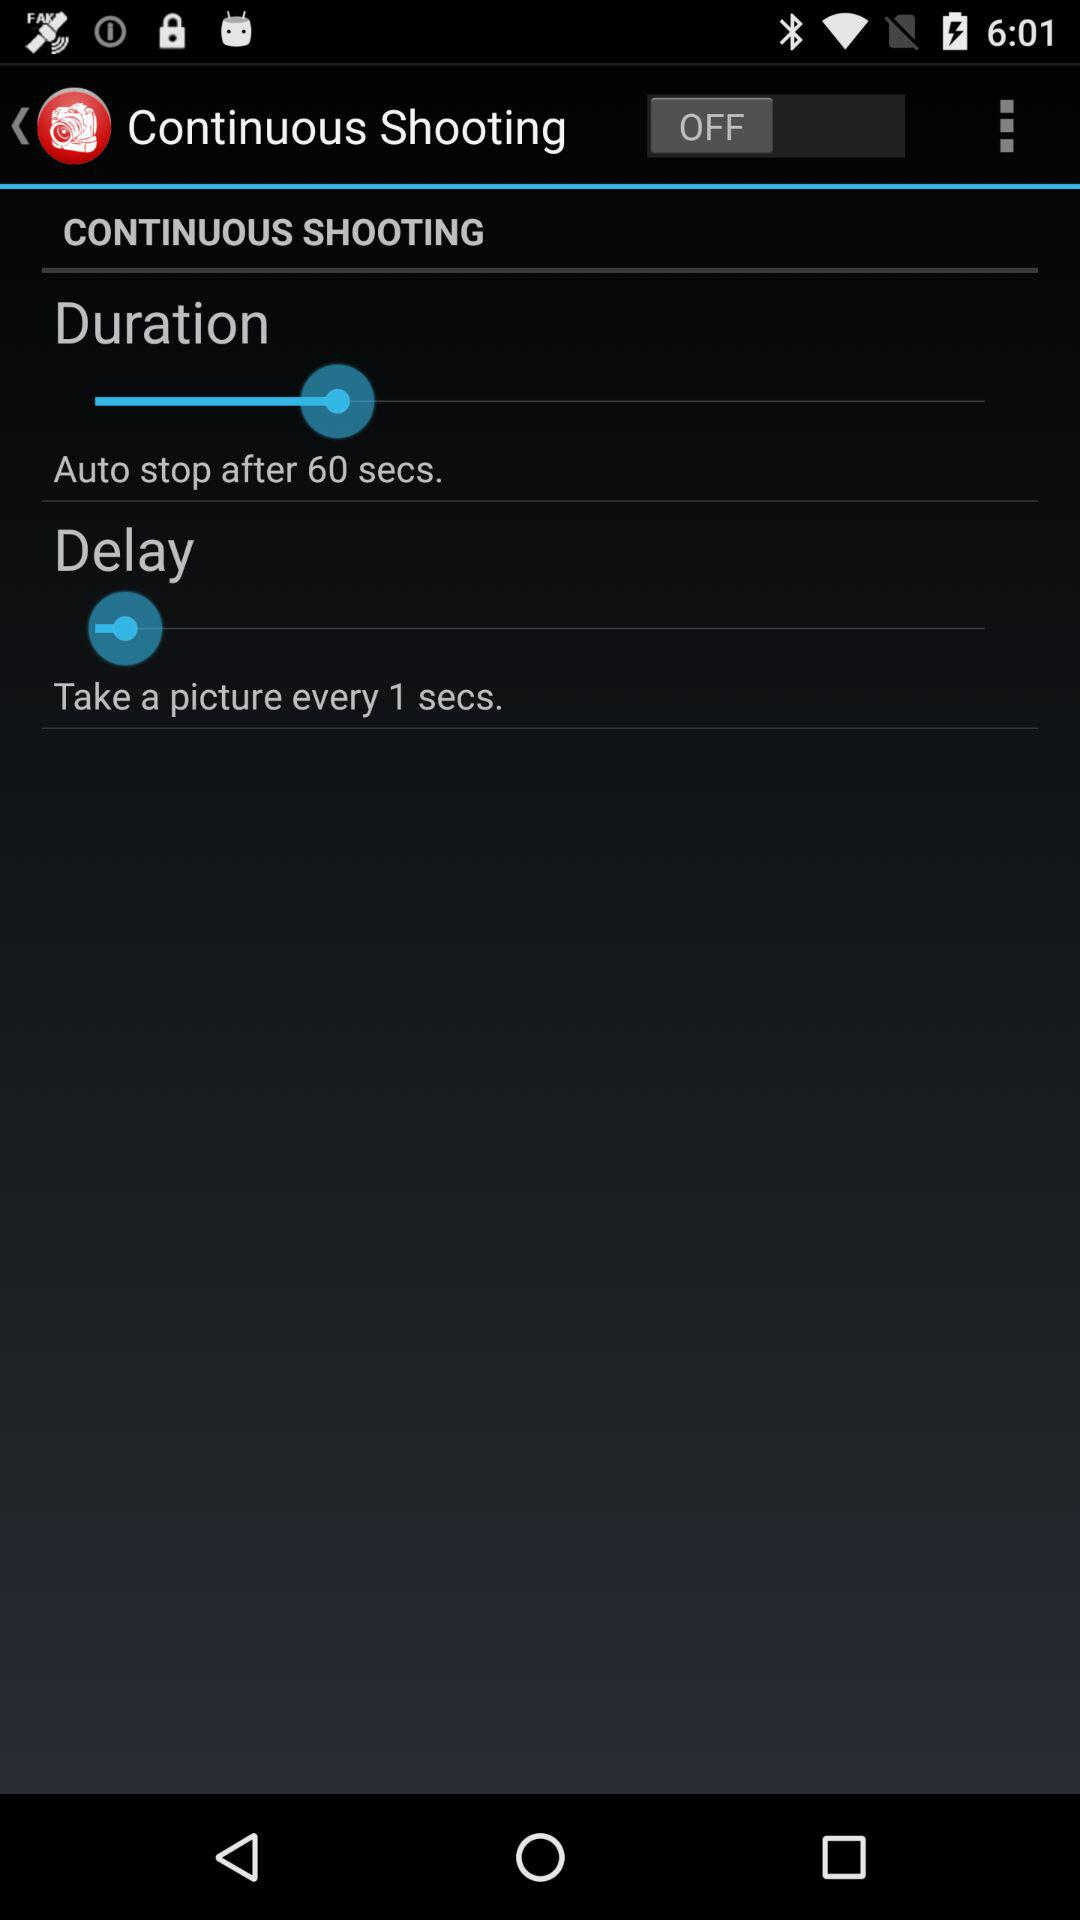How much is the delay time to take a picture? The delay time to take a picture is 1 second. 